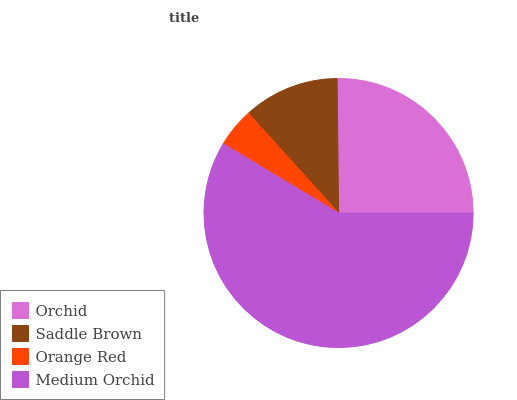Is Orange Red the minimum?
Answer yes or no. Yes. Is Medium Orchid the maximum?
Answer yes or no. Yes. Is Saddle Brown the minimum?
Answer yes or no. No. Is Saddle Brown the maximum?
Answer yes or no. No. Is Orchid greater than Saddle Brown?
Answer yes or no. Yes. Is Saddle Brown less than Orchid?
Answer yes or no. Yes. Is Saddle Brown greater than Orchid?
Answer yes or no. No. Is Orchid less than Saddle Brown?
Answer yes or no. No. Is Orchid the high median?
Answer yes or no. Yes. Is Saddle Brown the low median?
Answer yes or no. Yes. Is Saddle Brown the high median?
Answer yes or no. No. Is Orange Red the low median?
Answer yes or no. No. 